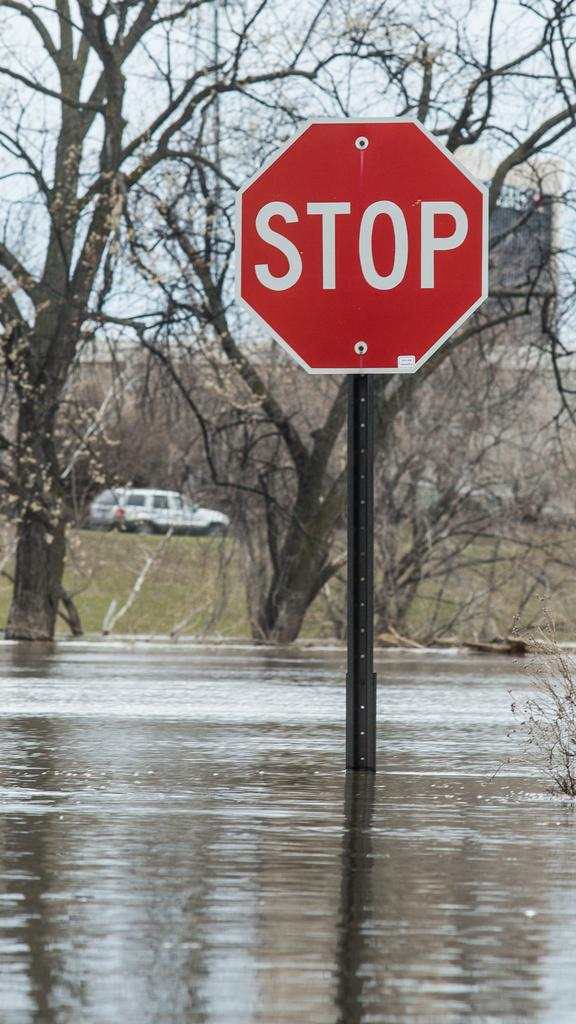<image>
Provide a brief description of the given image. The stop sign is now in a flooded area with water all around. 